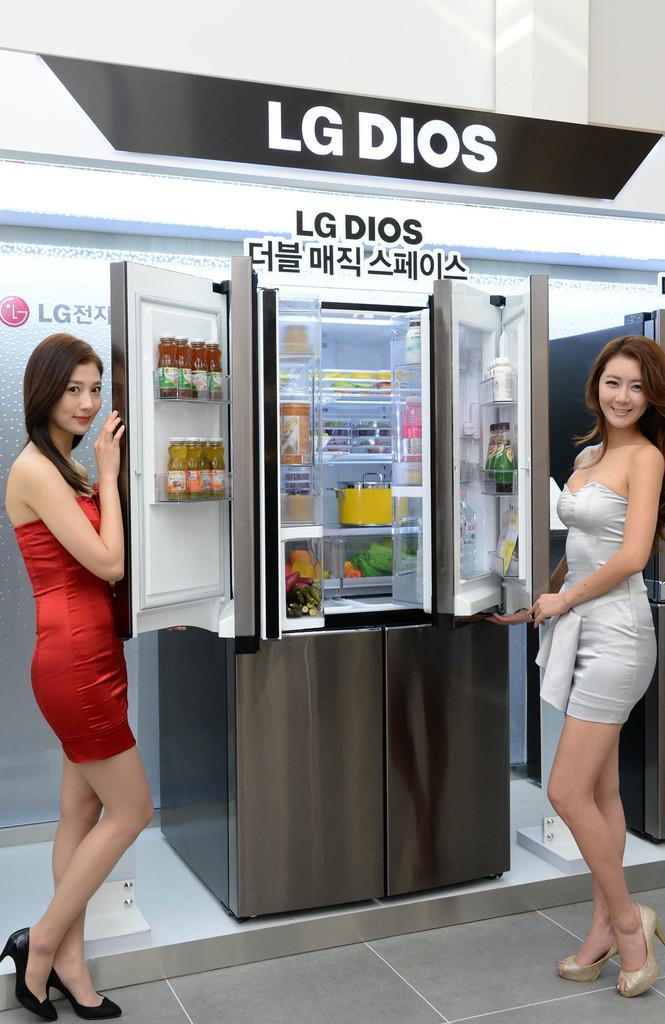<image>
Provide a brief description of the given image. two women standing in front a sign that says 'lg dios' on it 